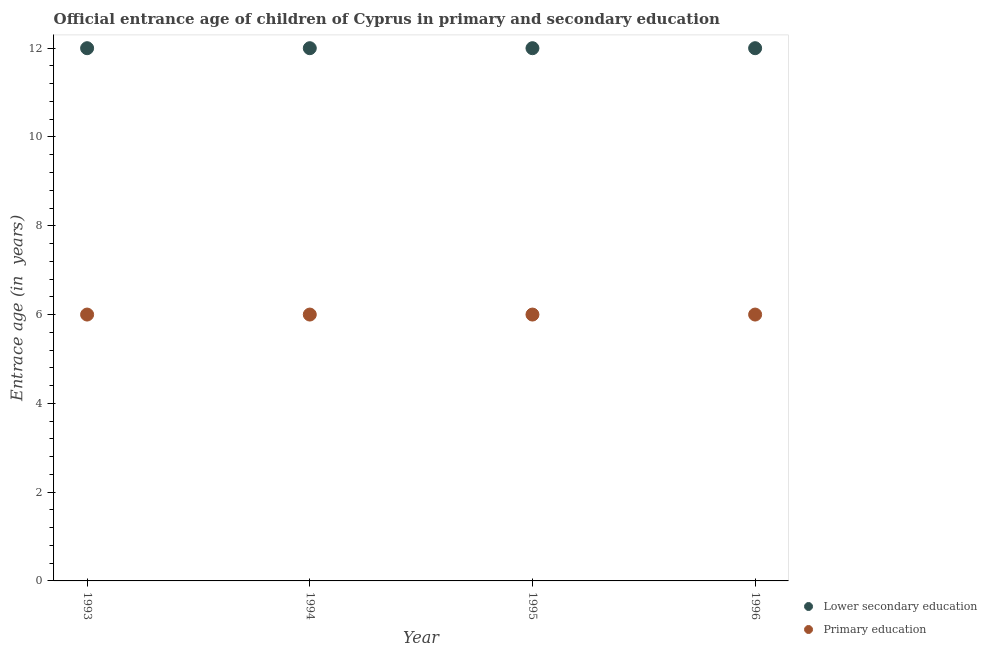How many different coloured dotlines are there?
Keep it short and to the point. 2. What is the entrance age of chiildren in primary education in 1993?
Make the answer very short. 6. Across all years, what is the maximum entrance age of children in lower secondary education?
Offer a very short reply. 12. Across all years, what is the minimum entrance age of children in lower secondary education?
Your response must be concise. 12. In which year was the entrance age of children in lower secondary education maximum?
Give a very brief answer. 1993. What is the total entrance age of chiildren in primary education in the graph?
Provide a succinct answer. 24. What is the difference between the entrance age of children in lower secondary education in 1994 and that in 1996?
Your answer should be compact. 0. What is the difference between the entrance age of chiildren in primary education in 1993 and the entrance age of children in lower secondary education in 1996?
Ensure brevity in your answer.  -6. What is the average entrance age of chiildren in primary education per year?
Give a very brief answer. 6. In the year 1993, what is the difference between the entrance age of children in lower secondary education and entrance age of chiildren in primary education?
Give a very brief answer. 6. In how many years, is the entrance age of chiildren in primary education greater than 3.2 years?
Make the answer very short. 4. What is the ratio of the entrance age of chiildren in primary education in 1993 to that in 1994?
Keep it short and to the point. 1. Is the entrance age of chiildren in primary education in 1994 less than that in 1996?
Your answer should be very brief. No. What is the difference between the highest and the lowest entrance age of chiildren in primary education?
Your answer should be compact. 0. In how many years, is the entrance age of chiildren in primary education greater than the average entrance age of chiildren in primary education taken over all years?
Give a very brief answer. 0. Is the sum of the entrance age of chiildren in primary education in 1993 and 1995 greater than the maximum entrance age of children in lower secondary education across all years?
Ensure brevity in your answer.  No. How many dotlines are there?
Provide a succinct answer. 2. Are the values on the major ticks of Y-axis written in scientific E-notation?
Provide a short and direct response. No. How many legend labels are there?
Ensure brevity in your answer.  2. How are the legend labels stacked?
Your answer should be compact. Vertical. What is the title of the graph?
Keep it short and to the point. Official entrance age of children of Cyprus in primary and secondary education. What is the label or title of the X-axis?
Offer a very short reply. Year. What is the label or title of the Y-axis?
Make the answer very short. Entrace age (in  years). What is the Entrace age (in  years) in Primary education in 1993?
Give a very brief answer. 6. What is the Entrace age (in  years) in Primary education in 1994?
Make the answer very short. 6. What is the Entrace age (in  years) in Lower secondary education in 1995?
Provide a short and direct response. 12. What is the Entrace age (in  years) of Primary education in 1995?
Keep it short and to the point. 6. Across all years, what is the maximum Entrace age (in  years) of Lower secondary education?
Your answer should be compact. 12. Across all years, what is the minimum Entrace age (in  years) of Lower secondary education?
Ensure brevity in your answer.  12. What is the total Entrace age (in  years) in Lower secondary education in the graph?
Your answer should be very brief. 48. What is the total Entrace age (in  years) in Primary education in the graph?
Offer a terse response. 24. What is the difference between the Entrace age (in  years) in Lower secondary education in 1993 and that in 1995?
Offer a terse response. 0. What is the difference between the Entrace age (in  years) in Lower secondary education in 1993 and that in 1996?
Make the answer very short. 0. What is the difference between the Entrace age (in  years) in Lower secondary education in 1994 and that in 1995?
Your answer should be compact. 0. What is the difference between the Entrace age (in  years) in Lower secondary education in 1994 and that in 1996?
Ensure brevity in your answer.  0. What is the difference between the Entrace age (in  years) of Primary education in 1994 and that in 1996?
Offer a terse response. 0. What is the difference between the Entrace age (in  years) in Lower secondary education in 1995 and that in 1996?
Give a very brief answer. 0. What is the difference between the Entrace age (in  years) of Lower secondary education in 1994 and the Entrace age (in  years) of Primary education in 1996?
Give a very brief answer. 6. In the year 1993, what is the difference between the Entrace age (in  years) in Lower secondary education and Entrace age (in  years) in Primary education?
Your response must be concise. 6. What is the ratio of the Entrace age (in  years) of Lower secondary education in 1993 to that in 1994?
Your answer should be compact. 1. What is the ratio of the Entrace age (in  years) in Primary education in 1993 to that in 1994?
Your response must be concise. 1. What is the ratio of the Entrace age (in  years) in Lower secondary education in 1993 to that in 1996?
Your answer should be very brief. 1. What is the ratio of the Entrace age (in  years) in Lower secondary education in 1995 to that in 1996?
Offer a very short reply. 1. What is the difference between the highest and the second highest Entrace age (in  years) of Lower secondary education?
Provide a succinct answer. 0. What is the difference between the highest and the second highest Entrace age (in  years) in Primary education?
Provide a short and direct response. 0. 